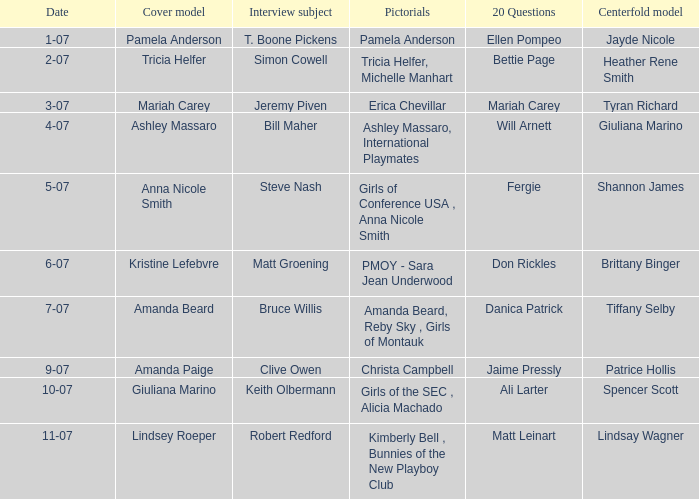Who was the centerfold model in the issue where Fergie answered the "20 questions"? Shannon James. 